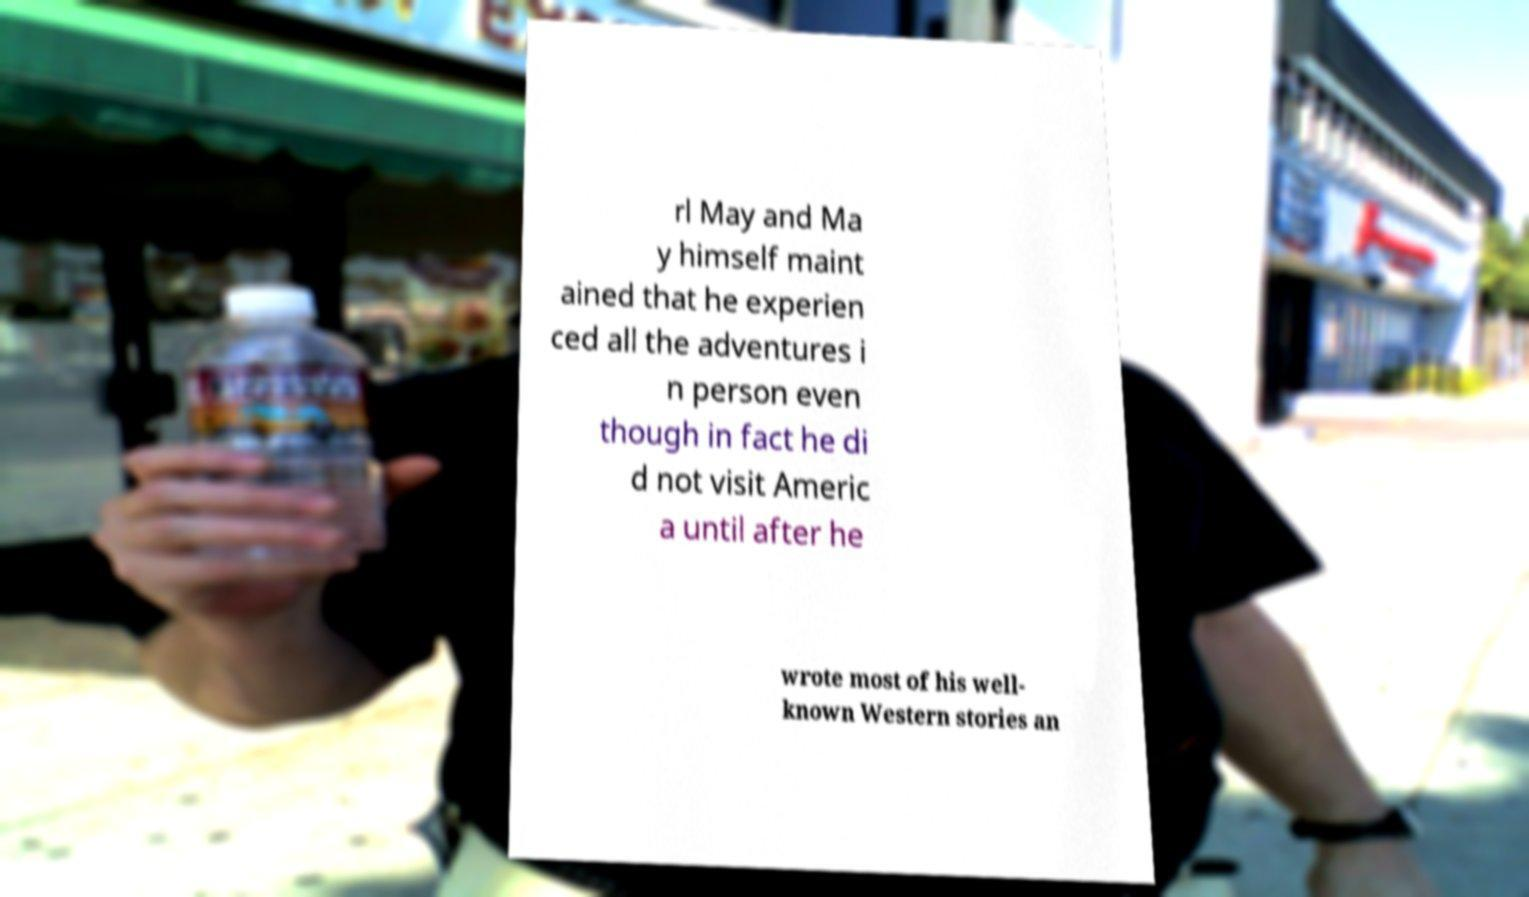For documentation purposes, I need the text within this image transcribed. Could you provide that? rl May and Ma y himself maint ained that he experien ced all the adventures i n person even though in fact he di d not visit Americ a until after he wrote most of his well- known Western stories an 